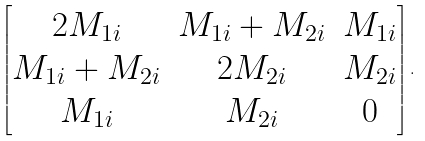Convert formula to latex. <formula><loc_0><loc_0><loc_500><loc_500>\begin{bmatrix} 2 M _ { 1 i } & M _ { 1 i } + M _ { 2 i } & M _ { 1 i } \\ M _ { 1 i } + M _ { 2 i } & 2 M _ { 2 i } & M _ { 2 i } \\ M _ { 1 i } & M _ { 2 i } & 0 \end{bmatrix} .</formula> 